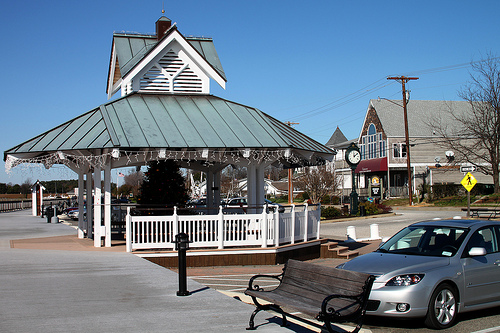Please provide a short description for this region: [0.65, 0.51, 0.99, 0.8]. The region specified by coordinates [0.65, 0.51, 0.99, 0.8] contains a metallic silver car. 